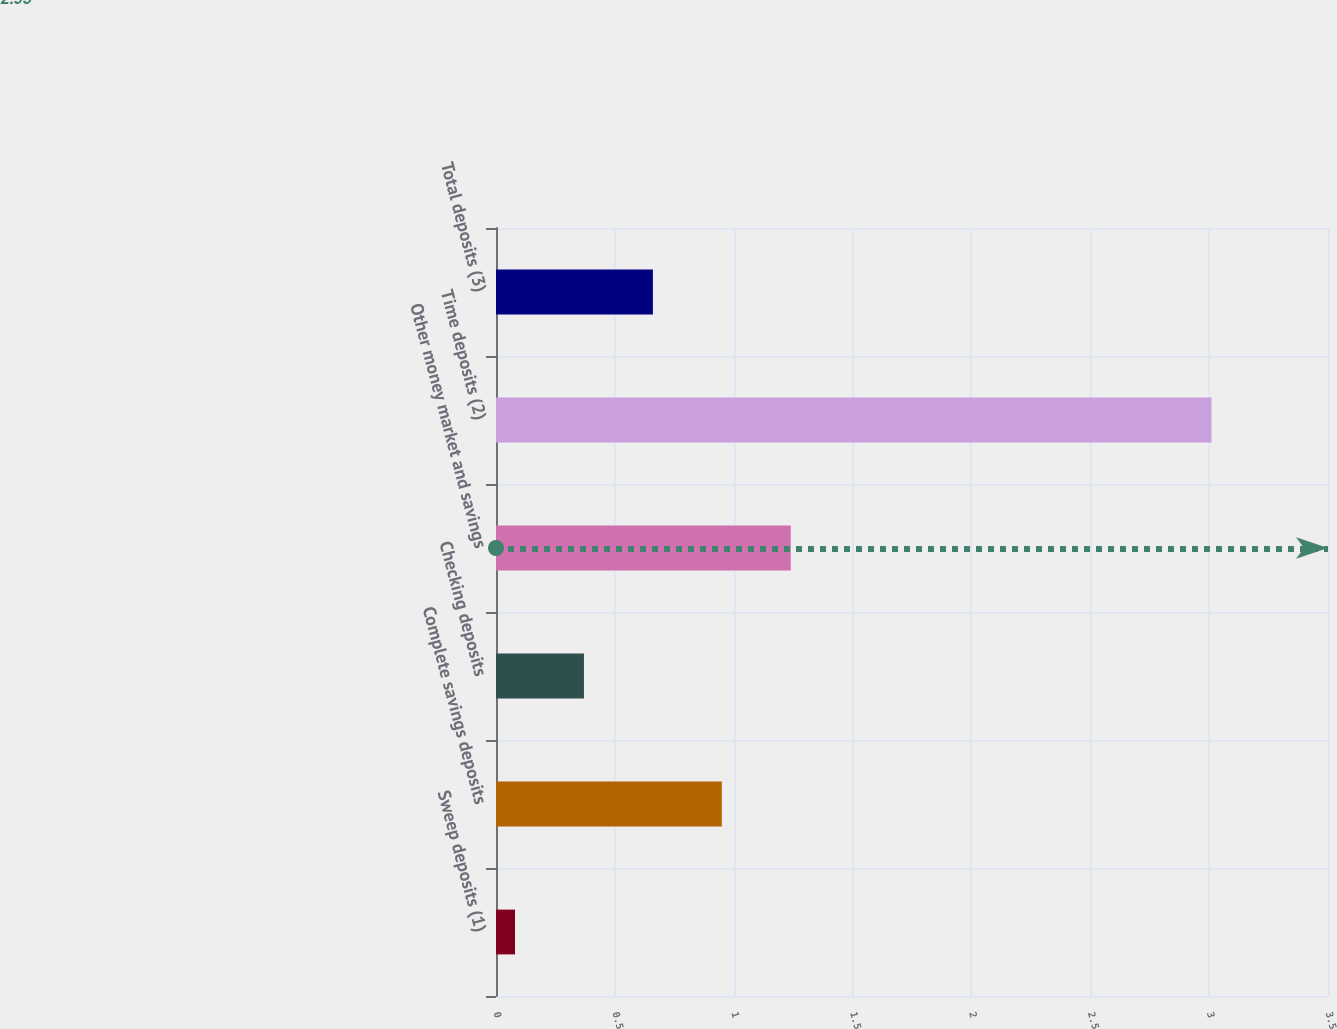Convert chart. <chart><loc_0><loc_0><loc_500><loc_500><bar_chart><fcel>Sweep deposits (1)<fcel>Complete savings deposits<fcel>Checking deposits<fcel>Other money market and savings<fcel>Time deposits (2)<fcel>Total deposits (3)<nl><fcel>0.08<fcel>0.95<fcel>0.37<fcel>1.24<fcel>3.01<fcel>0.66<nl></chart> 